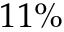<formula> <loc_0><loc_0><loc_500><loc_500>1 1 \%</formula> 